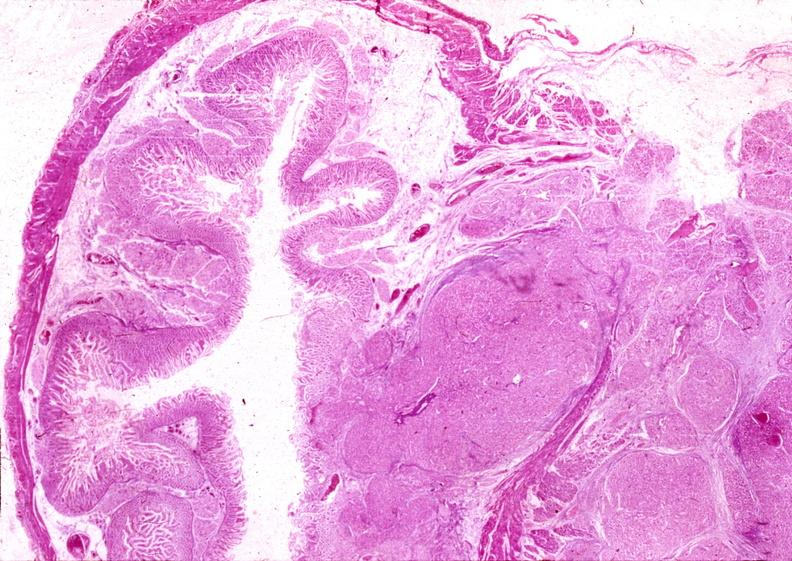does large cell lymphoma show islet cell carcinoma?
Answer the question using a single word or phrase. No 